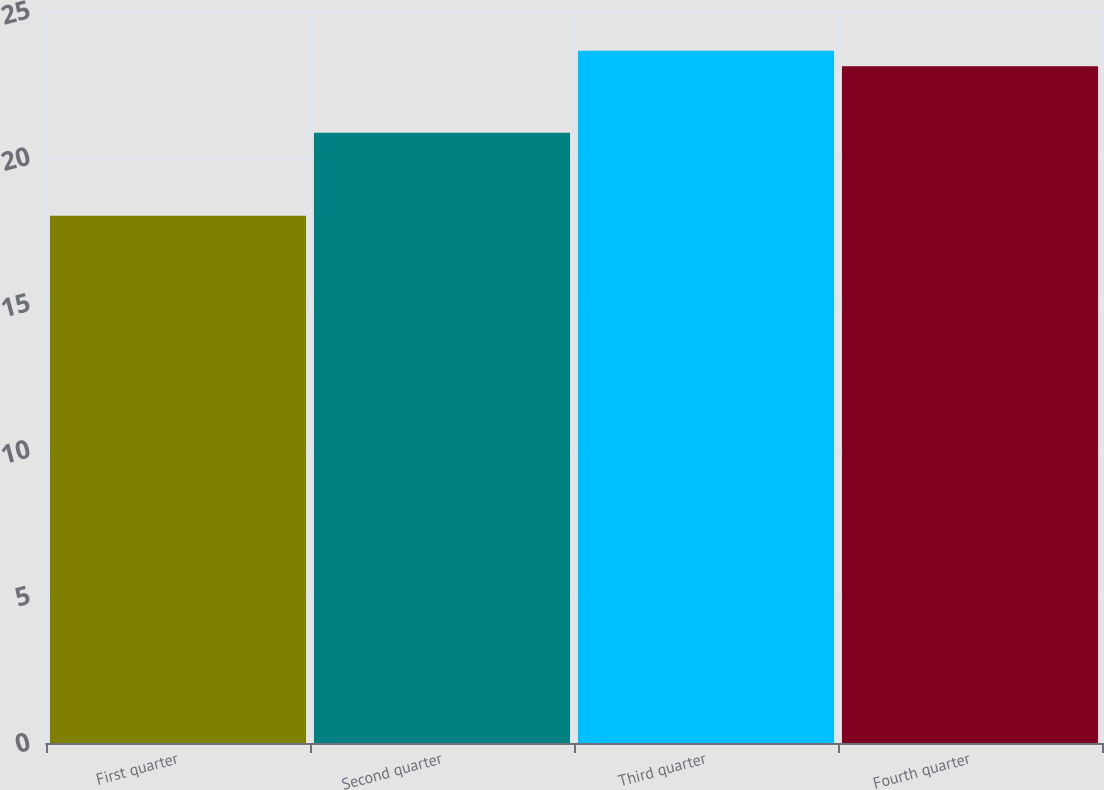Convert chart to OTSL. <chart><loc_0><loc_0><loc_500><loc_500><bar_chart><fcel>First quarter<fcel>Second quarter<fcel>Third quarter<fcel>Fourth quarter<nl><fcel>18.01<fcel>20.84<fcel>23.64<fcel>23.11<nl></chart> 